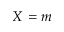Convert formula to latex. <formula><loc_0><loc_0><loc_500><loc_500>X = m</formula> 